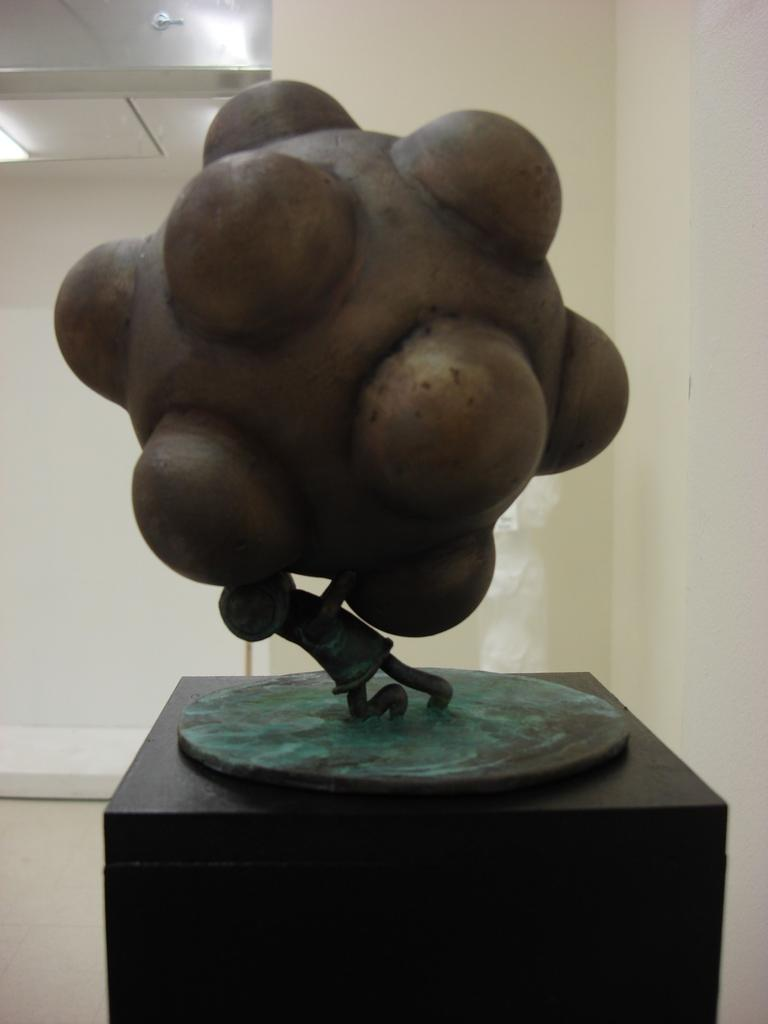What is the main subject of the image? There is a sculpture in the image. How is the sculpture positioned? The sculpture is placed on a stand. What can be seen in the background of the image? There is a wall in the background of the image. What is used to illuminate the sculpture? There are lights in the image. What is the title of the sculpture in the image? The provided facts do not mention the title of the sculpture, so we cannot determine it from the image. Is there any blood visible on the sculpture in the image? There is no mention of blood in the provided facts, and it is not visible in the image. 